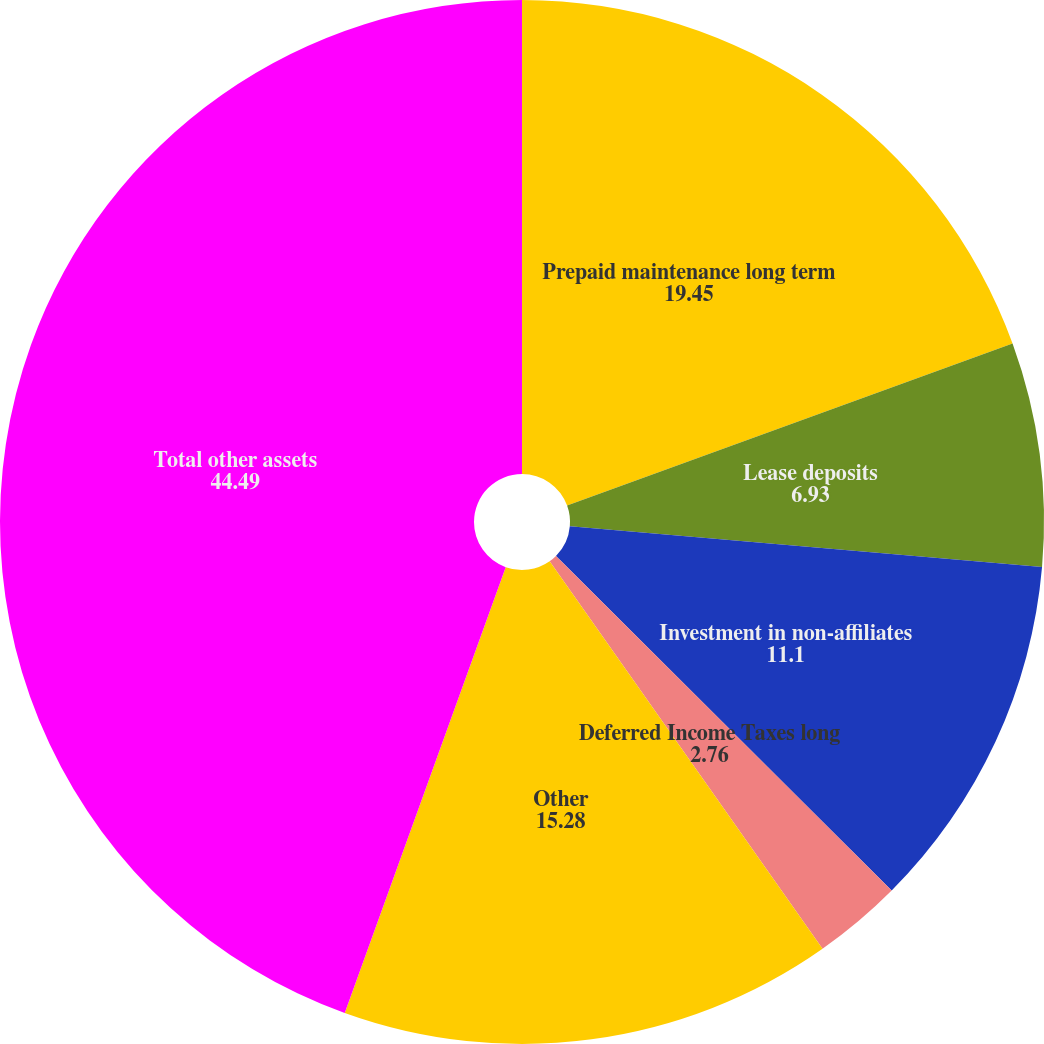Convert chart to OTSL. <chart><loc_0><loc_0><loc_500><loc_500><pie_chart><fcel>Prepaid maintenance long term<fcel>Lease deposits<fcel>Investment in non-affiliates<fcel>Deferred Income Taxes long<fcel>Other<fcel>Total other assets<nl><fcel>19.45%<fcel>6.93%<fcel>11.1%<fcel>2.76%<fcel>15.28%<fcel>44.49%<nl></chart> 